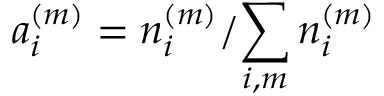<formula> <loc_0><loc_0><loc_500><loc_500>a _ { i } ^ { ( m ) } = { n _ { i } ^ { ( m ) } } / { \sum _ { i , m } n _ { i } ^ { ( m ) } }</formula> 